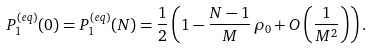Convert formula to latex. <formula><loc_0><loc_0><loc_500><loc_500>P _ { 1 } ^ { ( e q ) } ( 0 ) = P _ { 1 } ^ { ( e q ) } ( N ) = \frac { 1 } { 2 } \left ( 1 - \frac { N - 1 } { M } \, \rho _ { 0 } + O \left ( \frac { 1 } { M ^ { 2 } } \right ) \right ) .</formula> 